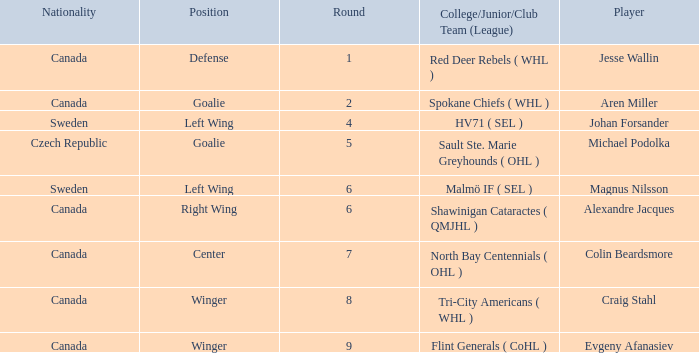What is the Nationality for alexandre jacques? Canada. 